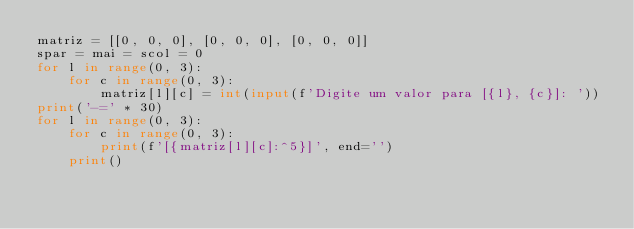<code> <loc_0><loc_0><loc_500><loc_500><_Python_>matriz = [[0, 0, 0], [0, 0, 0], [0, 0, 0]]
spar = mai = scol = 0
for l in range(0, 3):
    for c in range(0, 3):
        matriz[l][c] = int(input(f'Digite um valor para [{l}, {c}]: '))
print('-=' * 30)
for l in range(0, 3):
    for c in range(0, 3):
        print(f'[{matriz[l][c]:^5}]', end='')
    print()
</code> 